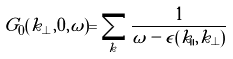<formula> <loc_0><loc_0><loc_500><loc_500>G _ { 0 } ( k _ { \perp } , 0 , \omega ) = \sum _ { k _ { \| } } \frac { 1 } { \omega - \epsilon ( k _ { \| } , k _ { \perp } ) }</formula> 